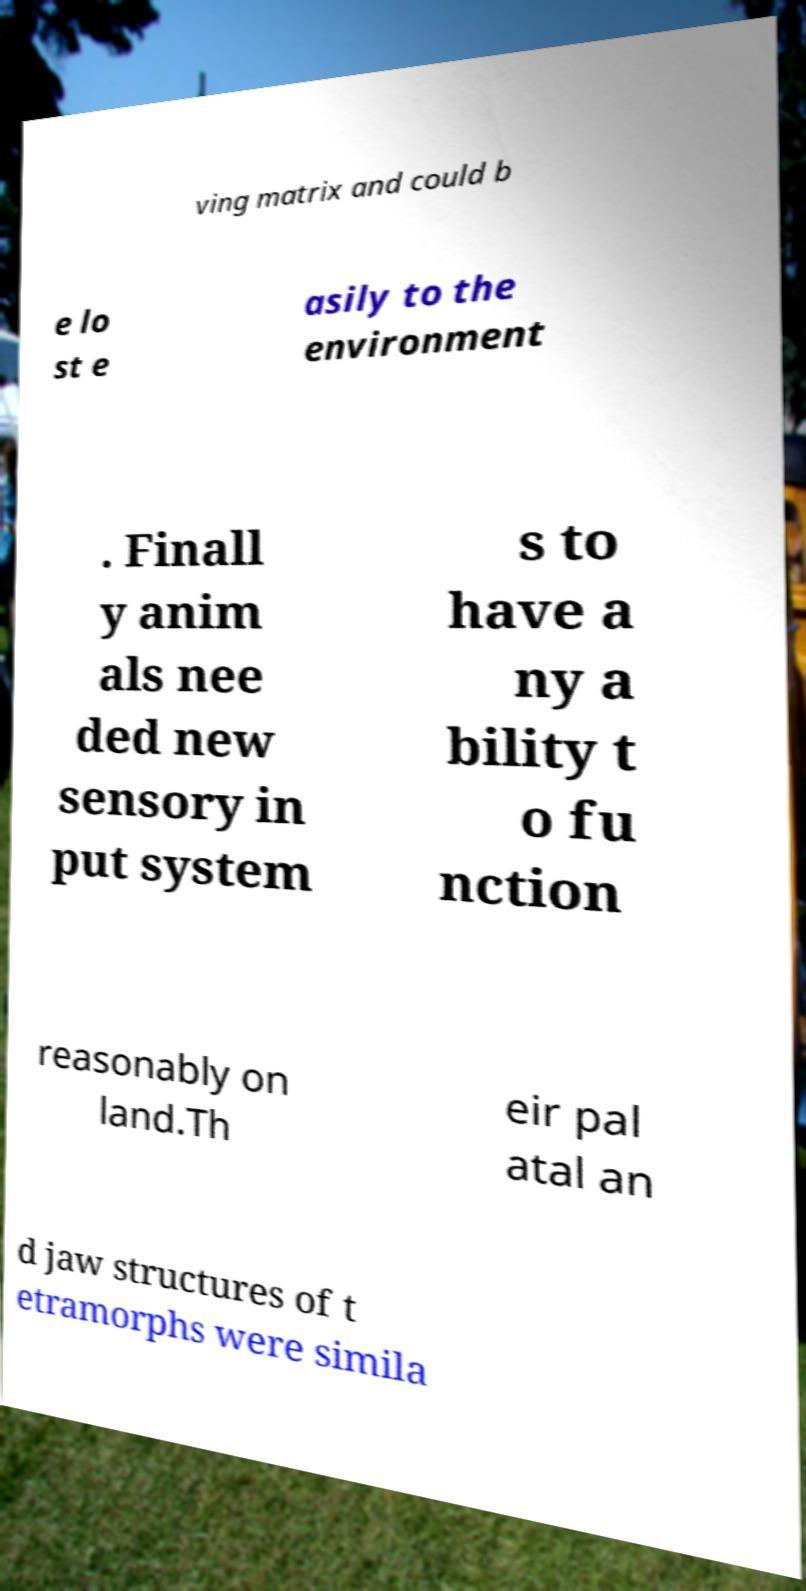Can you read and provide the text displayed in the image?This photo seems to have some interesting text. Can you extract and type it out for me? ving matrix and could b e lo st e asily to the environment . Finall y anim als nee ded new sensory in put system s to have a ny a bility t o fu nction reasonably on land.Th eir pal atal an d jaw structures of t etramorphs were simila 